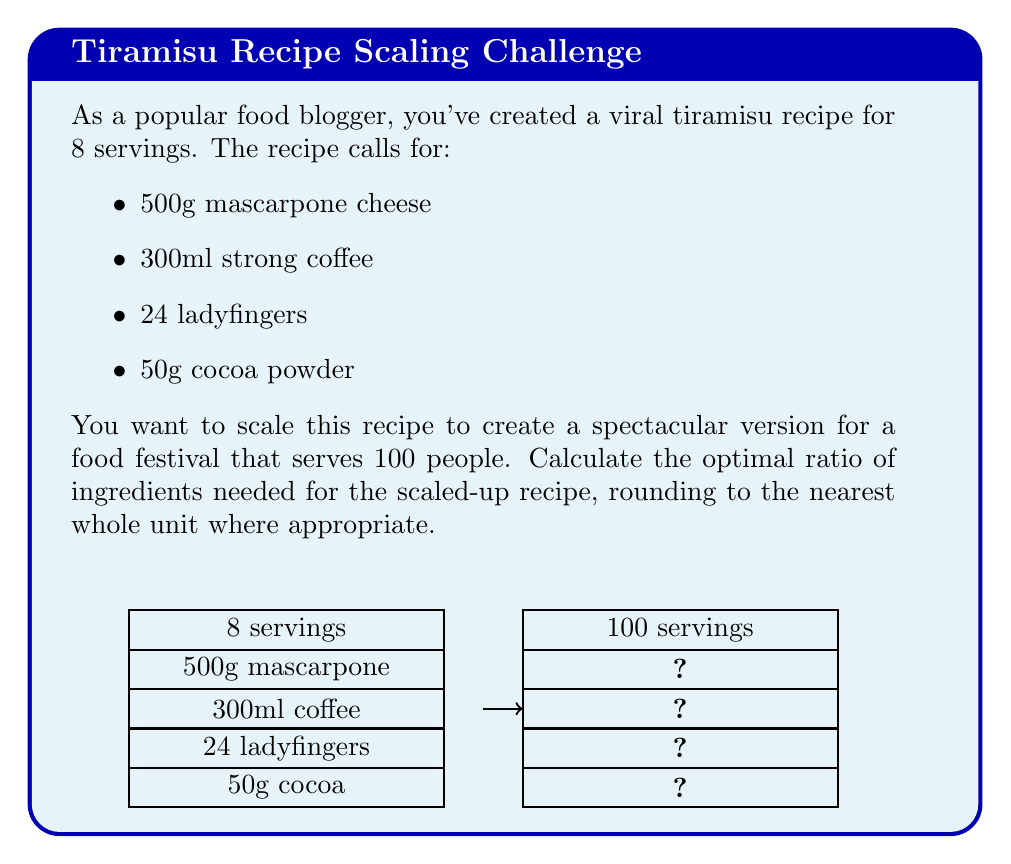Solve this math problem. To scale the recipe from 8 servings to 100 servings, we need to calculate the scaling factor and then multiply each ingredient by this factor.

Step 1: Calculate the scaling factor
$$ \text{Scaling factor} = \frac{\text{New number of servings}}{\text{Original number of servings}} = \frac{100}{8} = 12.5 $$

Step 2: Multiply each ingredient by the scaling factor and round to the nearest whole unit where appropriate

1. Mascarpone cheese:
   $500g \times 12.5 = 6250g$ (or 6.25kg)

2. Strong coffee:
   $300ml \times 12.5 = 3750ml$ (or 3.75L)

3. Ladyfingers:
   $24 \times 12.5 = 300$ ladyfingers

4. Cocoa powder:
   $50g \times 12.5 = 625g$

Step 3: Express the scaled ingredients as a ratio
To express this as a ratio, we'll use the smallest amount (cocoa powder) as the base unit:

$$ \frac{6250}{625} : \frac{3750}{625} : \frac{300}{625} : \frac{625}{625} $$

Simplifying:
$$ 10 : 6 : 0.48 : 1 $$

Rounding the ladyfingers to the nearest whole number:
$$ 10 : 6 : 0.5 : 1 $$

This ratio represents the optimal proportion of ingredients for the scaled-up recipe.
Answer: 10 : 6 : 0.5 : 1 